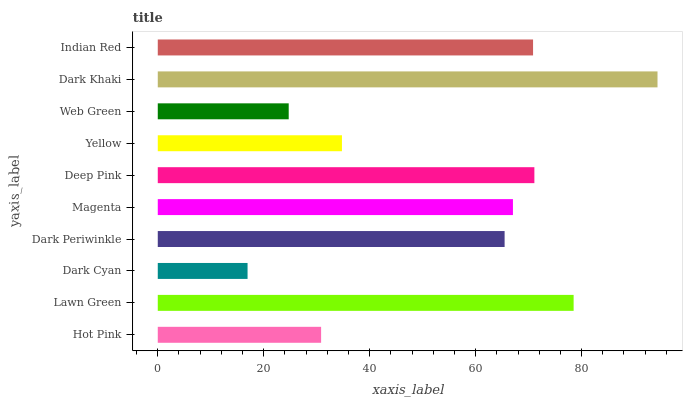Is Dark Cyan the minimum?
Answer yes or no. Yes. Is Dark Khaki the maximum?
Answer yes or no. Yes. Is Lawn Green the minimum?
Answer yes or no. No. Is Lawn Green the maximum?
Answer yes or no. No. Is Lawn Green greater than Hot Pink?
Answer yes or no. Yes. Is Hot Pink less than Lawn Green?
Answer yes or no. Yes. Is Hot Pink greater than Lawn Green?
Answer yes or no. No. Is Lawn Green less than Hot Pink?
Answer yes or no. No. Is Magenta the high median?
Answer yes or no. Yes. Is Dark Periwinkle the low median?
Answer yes or no. Yes. Is Web Green the high median?
Answer yes or no. No. Is Lawn Green the low median?
Answer yes or no. No. 